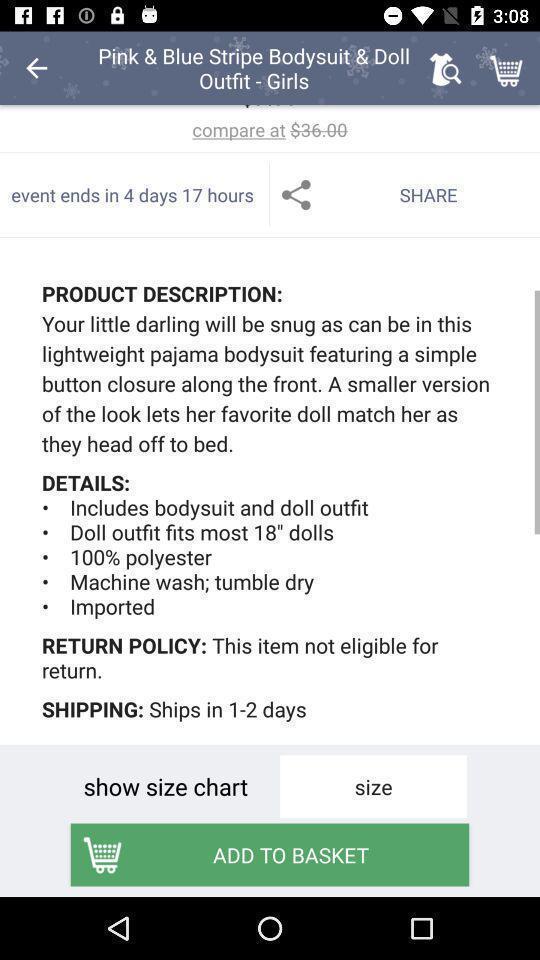Explain the elements present in this screenshot. Screen display description of a product. 